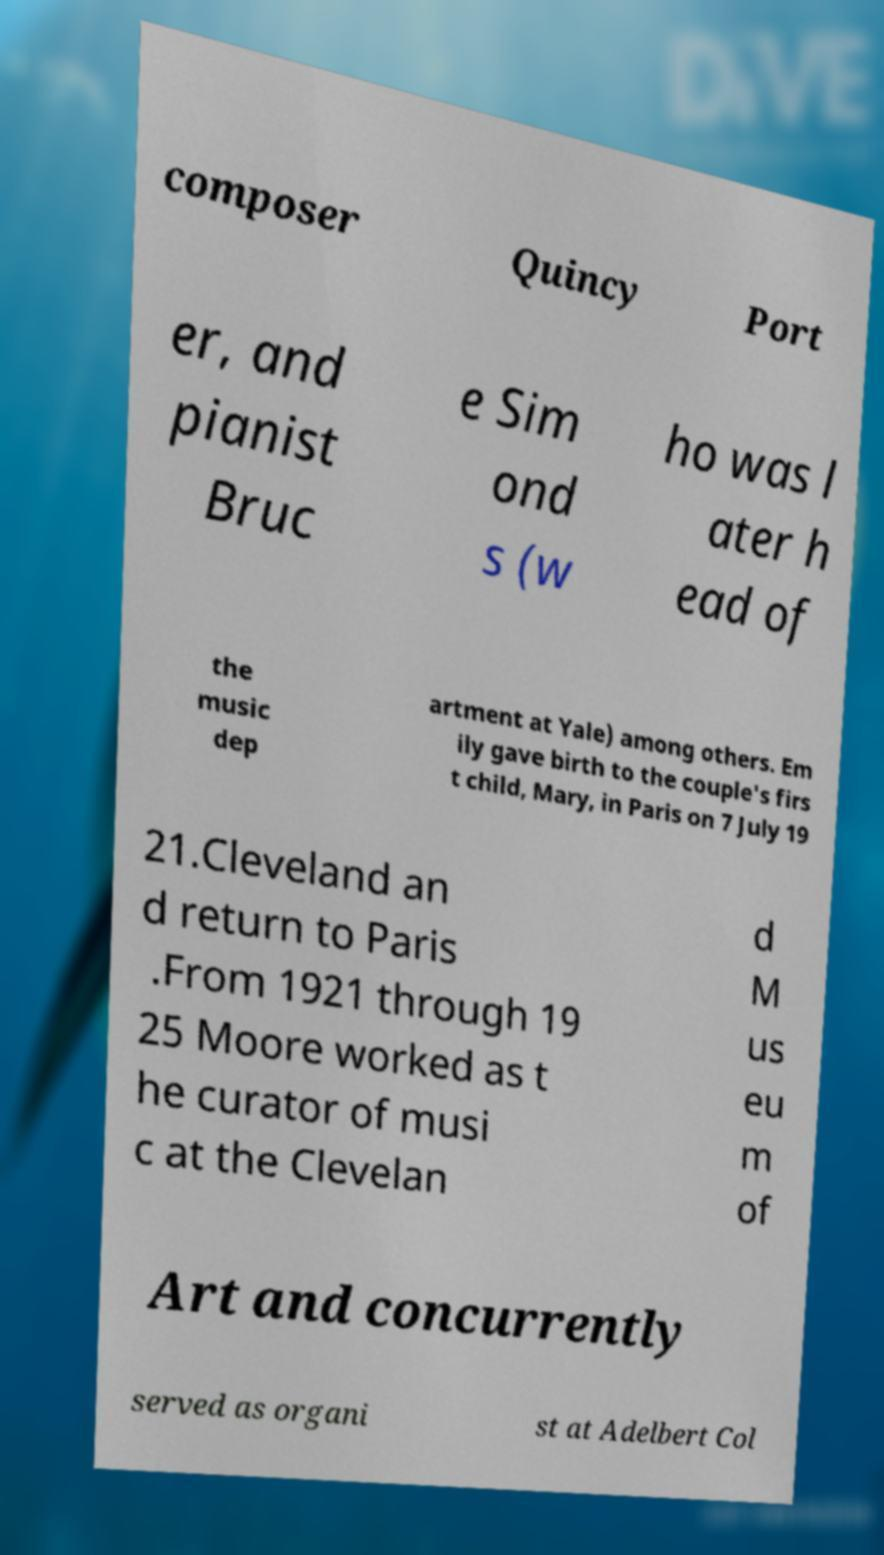Could you extract and type out the text from this image? composer Quincy Port er, and pianist Bruc e Sim ond s (w ho was l ater h ead of the music dep artment at Yale) among others. Em ily gave birth to the couple's firs t child, Mary, in Paris on 7 July 19 21.Cleveland an d return to Paris .From 1921 through 19 25 Moore worked as t he curator of musi c at the Clevelan d M us eu m of Art and concurrently served as organi st at Adelbert Col 